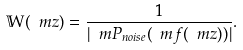Convert formula to latex. <formula><loc_0><loc_0><loc_500><loc_500>\mathbb { W } ( \ m z ) = \frac { 1 } { | \ m P _ { n o i s e } ( \ m f ( \ m z ) ) | } .</formula> 